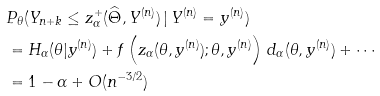<formula> <loc_0><loc_0><loc_500><loc_500>& P _ { \theta } ( Y _ { n + k } \leq z _ { \alpha } ^ { + } ( \widehat { \Theta } , Y ^ { ( n ) } ) \, | \, Y ^ { ( n ) } = y ^ { ( n ) } ) \\ & = H _ { \alpha } ( \theta | y ^ { ( n ) } ) + f \left ( z _ { \alpha } ( \theta , y ^ { ( n ) } ) ; \theta , y ^ { ( n ) } \right ) \, d _ { \alpha } ( \theta , y ^ { ( n ) } ) + \cdots \\ & = 1 - \alpha + O ( n ^ { - 3 / 2 } )</formula> 